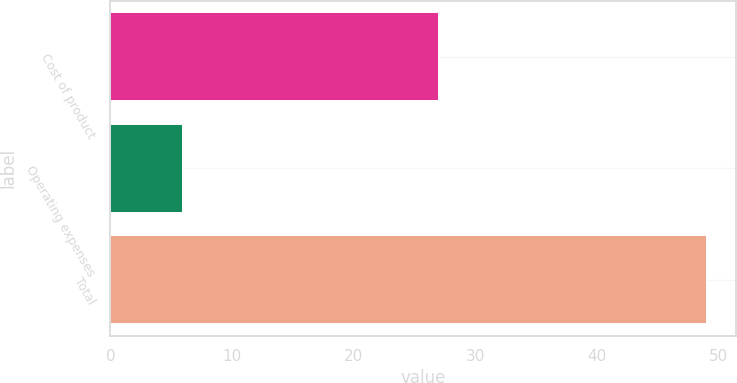Convert chart to OTSL. <chart><loc_0><loc_0><loc_500><loc_500><bar_chart><fcel>Cost of product<fcel>Operating expenses<fcel>Total<nl><fcel>27<fcel>6<fcel>49<nl></chart> 